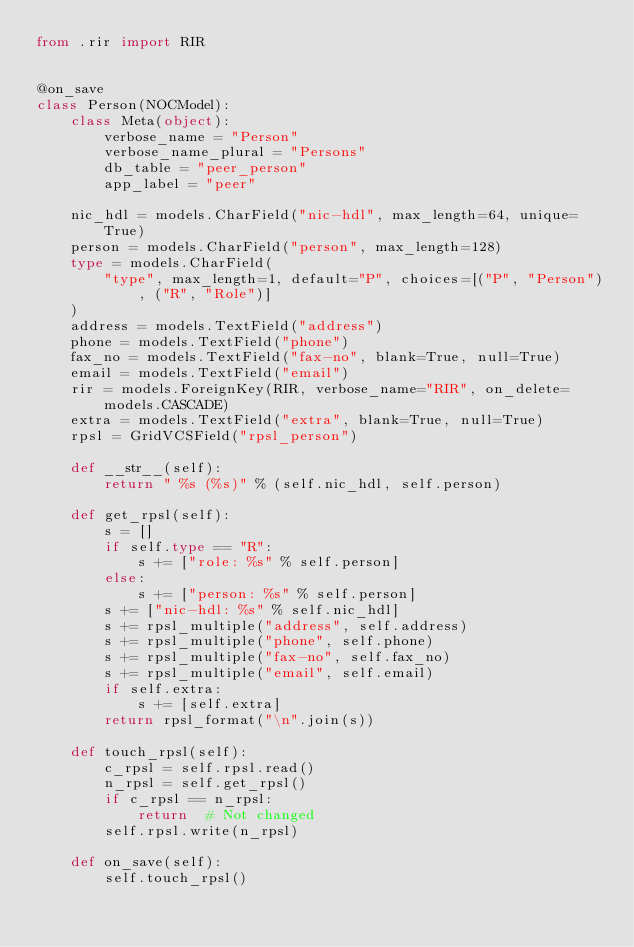Convert code to text. <code><loc_0><loc_0><loc_500><loc_500><_Python_>from .rir import RIR


@on_save
class Person(NOCModel):
    class Meta(object):
        verbose_name = "Person"
        verbose_name_plural = "Persons"
        db_table = "peer_person"
        app_label = "peer"

    nic_hdl = models.CharField("nic-hdl", max_length=64, unique=True)
    person = models.CharField("person", max_length=128)
    type = models.CharField(
        "type", max_length=1, default="P", choices=[("P", "Person"), ("R", "Role")]
    )
    address = models.TextField("address")
    phone = models.TextField("phone")
    fax_no = models.TextField("fax-no", blank=True, null=True)
    email = models.TextField("email")
    rir = models.ForeignKey(RIR, verbose_name="RIR", on_delete=models.CASCADE)
    extra = models.TextField("extra", blank=True, null=True)
    rpsl = GridVCSField("rpsl_person")

    def __str__(self):
        return " %s (%s)" % (self.nic_hdl, self.person)

    def get_rpsl(self):
        s = []
        if self.type == "R":
            s += ["role: %s" % self.person]
        else:
            s += ["person: %s" % self.person]
        s += ["nic-hdl: %s" % self.nic_hdl]
        s += rpsl_multiple("address", self.address)
        s += rpsl_multiple("phone", self.phone)
        s += rpsl_multiple("fax-no", self.fax_no)
        s += rpsl_multiple("email", self.email)
        if self.extra:
            s += [self.extra]
        return rpsl_format("\n".join(s))

    def touch_rpsl(self):
        c_rpsl = self.rpsl.read()
        n_rpsl = self.get_rpsl()
        if c_rpsl == n_rpsl:
            return  # Not changed
        self.rpsl.write(n_rpsl)

    def on_save(self):
        self.touch_rpsl()
</code> 